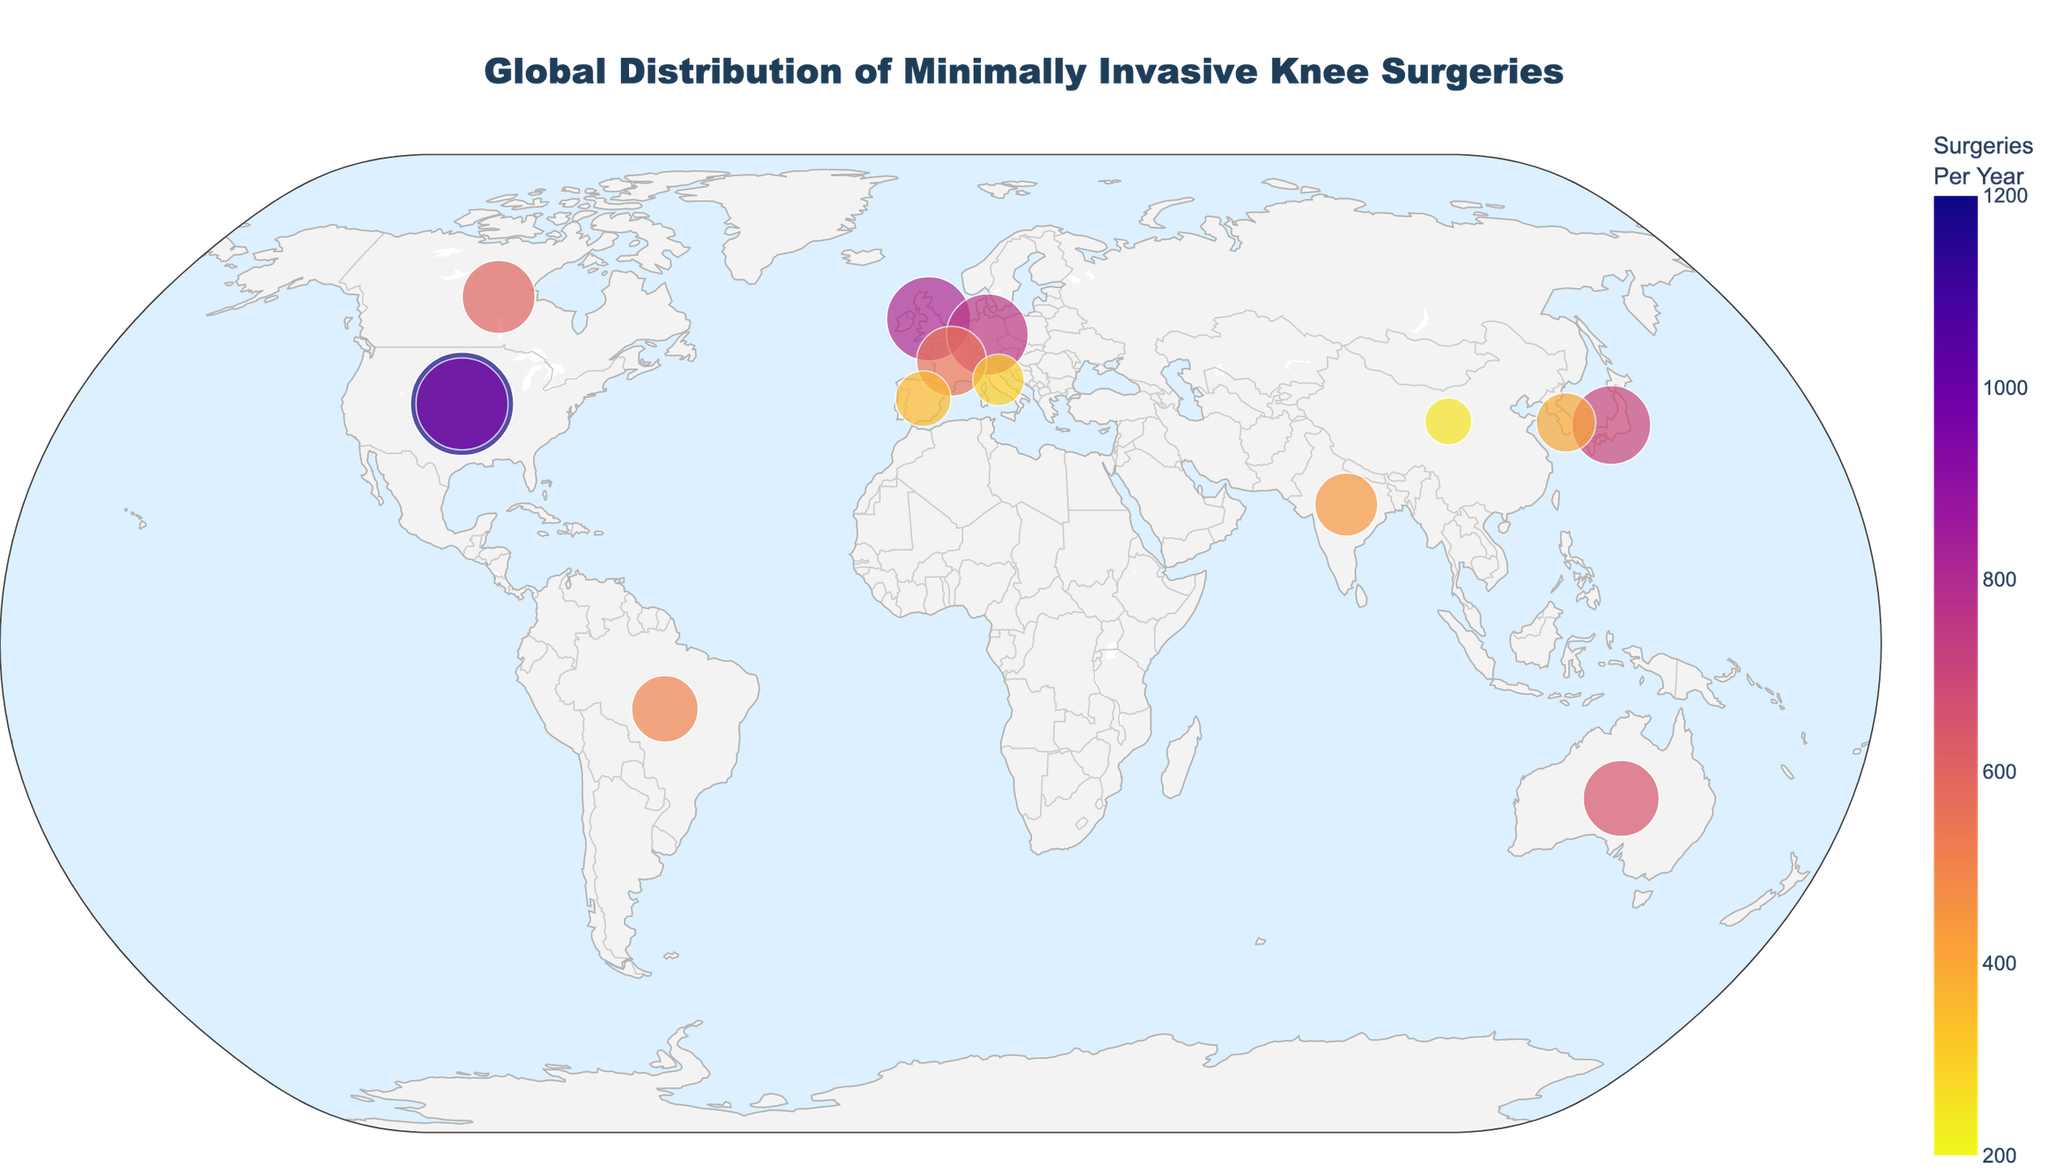What is the title of the figure? The title is displayed prominently at the top of the figure. It reads "Global Distribution of Minimally Invasive Knee Surgeries".
Answer: Global Distribution of Minimally Invasive Knee Surgeries Which medical center performs the highest number of minimally invasive knee surgeries per year? By interpreting the figure, you can see the largest data point located in the USA, New York. Hovering over it reveals the name "Hospital for Special Surgery" with 1200 surgeries per year.
Answer: Hospital for Special Surgery What country has the most medical centers shown on the map? By visual count of markers on the map, you observe that the USA has the most, with two centers: one in New York and one in Los Angeles.
Answer: USA What are the three cities where medical centers perform fewer than 300 surgeries per year? Look for the markers represented by smaller dots and hover over them. You will find medical centers in Milan (300 surgeries), Shanghai (250 surgeries), and Singapore (200 surgeries).
Answer: Milan, Shanghai, Singapore Which city in Europe performs the most minimally invasive knee surgeries per year? In Europe, the largest marker appears to be in London. Hovering over it reveals "The London Knee Clinic" with 800 surgeries per year.
Answer: London What is the average number of surgeries performed by medical centers in Asia? First, identify the medical centers in Asia: Tokyo (700), Mumbai (450), Seoul (400), Shanghai (250), Singapore (200). Calculate the total (700+450+400+250+200=2000) and then divide by the number of centers (5).
Answer: 400 How many surgeries per year are performed by medical centers in both Sydney and Toronto combined? Sum the surgeries of the Sydney center (650) and the Toronto center (600): 650 + 600 = 1250.
Answer: 1250 Which city in South America is represented on the map, and how many surgeries does its medical center perform per year? The figure shows a marker in São Paulo, Brazil. Hovering over it reveals "Hospital Israelita Albert Einstein" with 500 surgeries per year.
Answer: São Paulo, 500 In which continent do the medical centers perform fewer than 500 surgeries per year and how many centers are there? By examining the geographic spread and values, you find medical centers in Europe: Milan (300) and Barcelona (350).
Answer: Europe, 2 What is the smallest number of surgeries recorded by any of the medical centers, and which center is it? The smallest marker on the figure is located in Singapore, showing the Mount Elizabeth Novena Hospital with 200 surgeries per year.
Answer: 200, Mount Elizabeth Novena Hospital 